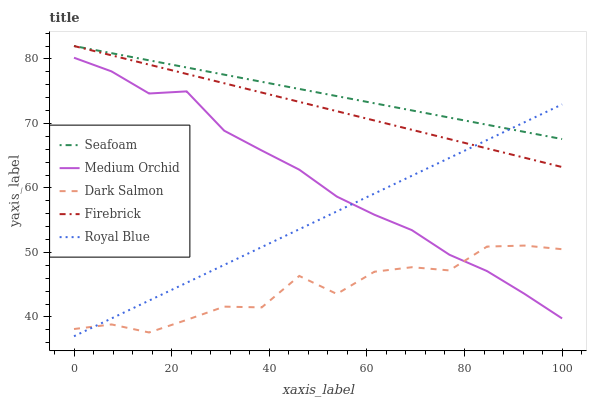Does Firebrick have the minimum area under the curve?
Answer yes or no. No. Does Firebrick have the maximum area under the curve?
Answer yes or no. No. Is Firebrick the smoothest?
Answer yes or no. No. Is Firebrick the roughest?
Answer yes or no. No. Does Firebrick have the lowest value?
Answer yes or no. No. Does Medium Orchid have the highest value?
Answer yes or no. No. Is Medium Orchid less than Firebrick?
Answer yes or no. Yes. Is Firebrick greater than Dark Salmon?
Answer yes or no. Yes. Does Medium Orchid intersect Firebrick?
Answer yes or no. No. 